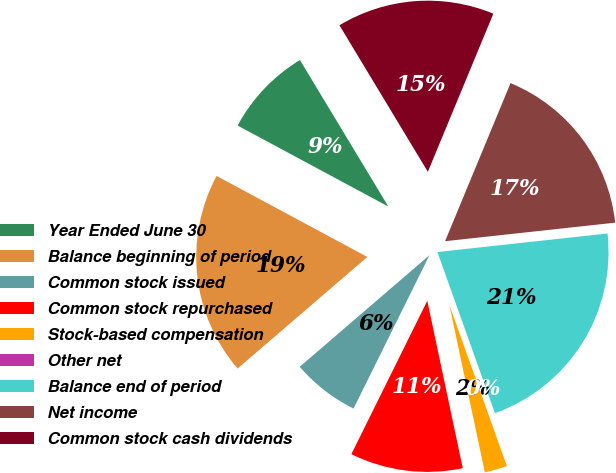<chart> <loc_0><loc_0><loc_500><loc_500><pie_chart><fcel>Year Ended June 30<fcel>Balance beginning of period<fcel>Common stock issued<fcel>Common stock repurchased<fcel>Stock-based compensation<fcel>Other net<fcel>Balance end of period<fcel>Net income<fcel>Common stock cash dividends<nl><fcel>8.51%<fcel>19.15%<fcel>6.38%<fcel>10.64%<fcel>2.13%<fcel>0.0%<fcel>21.27%<fcel>17.02%<fcel>14.89%<nl></chart> 